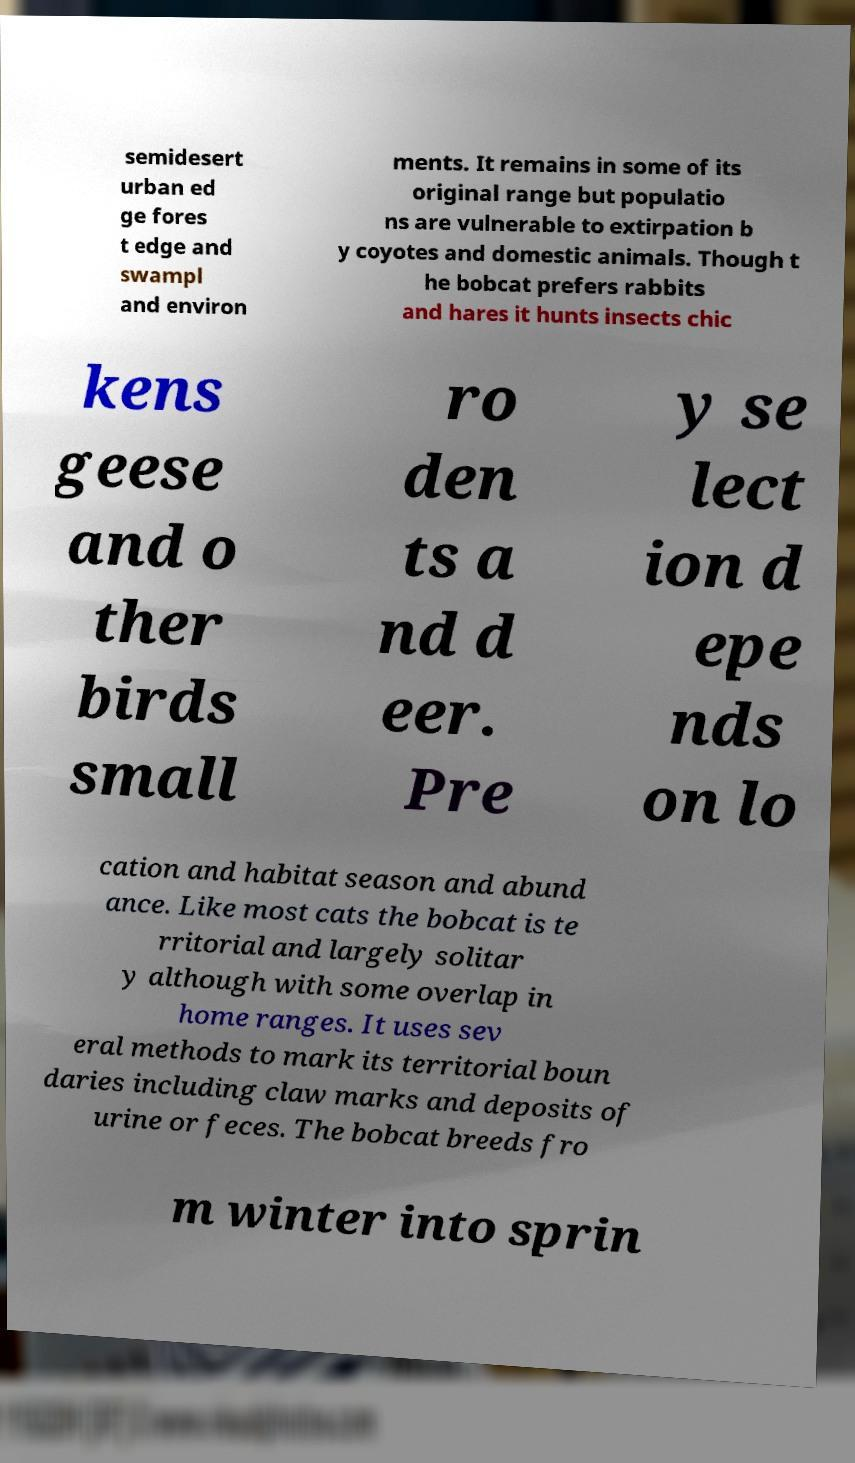I need the written content from this picture converted into text. Can you do that? semidesert urban ed ge fores t edge and swampl and environ ments. It remains in some of its original range but populatio ns are vulnerable to extirpation b y coyotes and domestic animals. Though t he bobcat prefers rabbits and hares it hunts insects chic kens geese and o ther birds small ro den ts a nd d eer. Pre y se lect ion d epe nds on lo cation and habitat season and abund ance. Like most cats the bobcat is te rritorial and largely solitar y although with some overlap in home ranges. It uses sev eral methods to mark its territorial boun daries including claw marks and deposits of urine or feces. The bobcat breeds fro m winter into sprin 